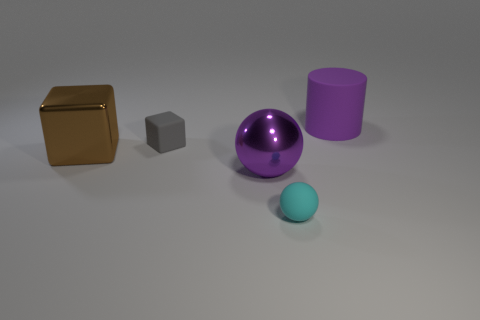Can you describe the colors of the objects in the image? Certainly! There's a large brown metal cube, a shiny purple sphere, a grey small cube, and a blue small sphere. Additionally, there is a violet cylinder. 